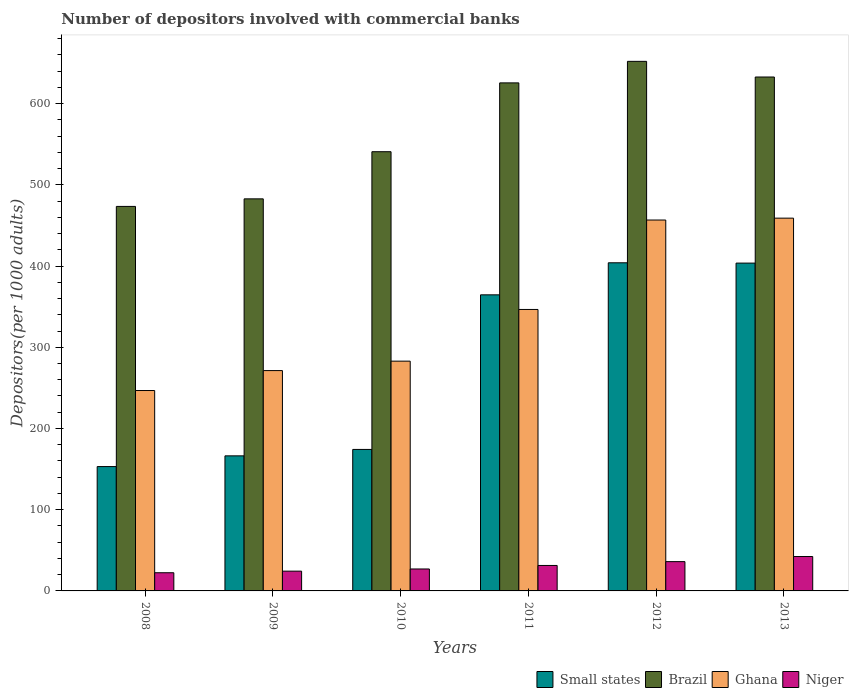How many groups of bars are there?
Offer a terse response. 6. Are the number of bars per tick equal to the number of legend labels?
Offer a terse response. Yes. What is the label of the 3rd group of bars from the left?
Give a very brief answer. 2010. What is the number of depositors involved with commercial banks in Niger in 2010?
Keep it short and to the point. 27.03. Across all years, what is the maximum number of depositors involved with commercial banks in Ghana?
Offer a terse response. 458.97. Across all years, what is the minimum number of depositors involved with commercial banks in Small states?
Offer a terse response. 153.11. In which year was the number of depositors involved with commercial banks in Brazil maximum?
Your response must be concise. 2012. In which year was the number of depositors involved with commercial banks in Brazil minimum?
Your answer should be compact. 2008. What is the total number of depositors involved with commercial banks in Brazil in the graph?
Your response must be concise. 3407.29. What is the difference between the number of depositors involved with commercial banks in Small states in 2012 and that in 2013?
Give a very brief answer. 0.38. What is the difference between the number of depositors involved with commercial banks in Small states in 2008 and the number of depositors involved with commercial banks in Niger in 2012?
Provide a succinct answer. 117.05. What is the average number of depositors involved with commercial banks in Brazil per year?
Your answer should be very brief. 567.88. In the year 2008, what is the difference between the number of depositors involved with commercial banks in Small states and number of depositors involved with commercial banks in Niger?
Provide a succinct answer. 130.72. In how many years, is the number of depositors involved with commercial banks in Ghana greater than 440?
Keep it short and to the point. 2. What is the ratio of the number of depositors involved with commercial banks in Small states in 2009 to that in 2011?
Provide a succinct answer. 0.46. What is the difference between the highest and the second highest number of depositors involved with commercial banks in Small states?
Offer a terse response. 0.38. What is the difference between the highest and the lowest number of depositors involved with commercial banks in Brazil?
Your answer should be very brief. 178.62. Is the sum of the number of depositors involved with commercial banks in Ghana in 2008 and 2011 greater than the maximum number of depositors involved with commercial banks in Niger across all years?
Offer a terse response. Yes. Is it the case that in every year, the sum of the number of depositors involved with commercial banks in Brazil and number of depositors involved with commercial banks in Niger is greater than the sum of number of depositors involved with commercial banks in Ghana and number of depositors involved with commercial banks in Small states?
Give a very brief answer. Yes. What does the 4th bar from the left in 2012 represents?
Provide a short and direct response. Niger. What does the 4th bar from the right in 2009 represents?
Ensure brevity in your answer.  Small states. How many bars are there?
Offer a terse response. 24. Are all the bars in the graph horizontal?
Make the answer very short. No. Does the graph contain any zero values?
Offer a very short reply. No. Where does the legend appear in the graph?
Offer a terse response. Bottom right. How are the legend labels stacked?
Offer a terse response. Horizontal. What is the title of the graph?
Your answer should be very brief. Number of depositors involved with commercial banks. What is the label or title of the X-axis?
Ensure brevity in your answer.  Years. What is the label or title of the Y-axis?
Provide a short and direct response. Depositors(per 1000 adults). What is the Depositors(per 1000 adults) in Small states in 2008?
Provide a succinct answer. 153.11. What is the Depositors(per 1000 adults) in Brazil in 2008?
Give a very brief answer. 473.42. What is the Depositors(per 1000 adults) of Ghana in 2008?
Your answer should be very brief. 246.75. What is the Depositors(per 1000 adults) of Niger in 2008?
Keep it short and to the point. 22.38. What is the Depositors(per 1000 adults) in Small states in 2009?
Provide a succinct answer. 166.31. What is the Depositors(per 1000 adults) in Brazil in 2009?
Offer a very short reply. 482.74. What is the Depositors(per 1000 adults) of Ghana in 2009?
Provide a short and direct response. 271.28. What is the Depositors(per 1000 adults) of Niger in 2009?
Ensure brevity in your answer.  24.34. What is the Depositors(per 1000 adults) of Small states in 2010?
Your answer should be very brief. 174.21. What is the Depositors(per 1000 adults) of Brazil in 2010?
Provide a short and direct response. 540.79. What is the Depositors(per 1000 adults) of Ghana in 2010?
Provide a succinct answer. 282.91. What is the Depositors(per 1000 adults) in Niger in 2010?
Provide a short and direct response. 27.03. What is the Depositors(per 1000 adults) in Small states in 2011?
Provide a short and direct response. 364.57. What is the Depositors(per 1000 adults) of Brazil in 2011?
Make the answer very short. 625.53. What is the Depositors(per 1000 adults) of Ghana in 2011?
Your response must be concise. 346.55. What is the Depositors(per 1000 adults) of Niger in 2011?
Your answer should be compact. 31.35. What is the Depositors(per 1000 adults) of Small states in 2012?
Make the answer very short. 404.02. What is the Depositors(per 1000 adults) in Brazil in 2012?
Your answer should be compact. 652.04. What is the Depositors(per 1000 adults) of Ghana in 2012?
Make the answer very short. 456.67. What is the Depositors(per 1000 adults) in Niger in 2012?
Your answer should be compact. 36.05. What is the Depositors(per 1000 adults) in Small states in 2013?
Provide a short and direct response. 403.64. What is the Depositors(per 1000 adults) of Brazil in 2013?
Provide a succinct answer. 632.77. What is the Depositors(per 1000 adults) of Ghana in 2013?
Offer a very short reply. 458.97. What is the Depositors(per 1000 adults) in Niger in 2013?
Offer a terse response. 42.35. Across all years, what is the maximum Depositors(per 1000 adults) in Small states?
Offer a very short reply. 404.02. Across all years, what is the maximum Depositors(per 1000 adults) in Brazil?
Offer a very short reply. 652.04. Across all years, what is the maximum Depositors(per 1000 adults) in Ghana?
Offer a terse response. 458.97. Across all years, what is the maximum Depositors(per 1000 adults) of Niger?
Your answer should be compact. 42.35. Across all years, what is the minimum Depositors(per 1000 adults) in Small states?
Offer a terse response. 153.11. Across all years, what is the minimum Depositors(per 1000 adults) of Brazil?
Keep it short and to the point. 473.42. Across all years, what is the minimum Depositors(per 1000 adults) of Ghana?
Offer a very short reply. 246.75. Across all years, what is the minimum Depositors(per 1000 adults) of Niger?
Provide a succinct answer. 22.38. What is the total Depositors(per 1000 adults) in Small states in the graph?
Ensure brevity in your answer.  1665.85. What is the total Depositors(per 1000 adults) in Brazil in the graph?
Offer a terse response. 3407.29. What is the total Depositors(per 1000 adults) of Ghana in the graph?
Ensure brevity in your answer.  2063.13. What is the total Depositors(per 1000 adults) of Niger in the graph?
Your answer should be compact. 183.51. What is the difference between the Depositors(per 1000 adults) in Small states in 2008 and that in 2009?
Provide a succinct answer. -13.2. What is the difference between the Depositors(per 1000 adults) of Brazil in 2008 and that in 2009?
Your response must be concise. -9.32. What is the difference between the Depositors(per 1000 adults) of Ghana in 2008 and that in 2009?
Your answer should be very brief. -24.54. What is the difference between the Depositors(per 1000 adults) in Niger in 2008 and that in 2009?
Offer a very short reply. -1.96. What is the difference between the Depositors(per 1000 adults) in Small states in 2008 and that in 2010?
Provide a succinct answer. -21.11. What is the difference between the Depositors(per 1000 adults) of Brazil in 2008 and that in 2010?
Your answer should be compact. -67.37. What is the difference between the Depositors(per 1000 adults) in Ghana in 2008 and that in 2010?
Your answer should be very brief. -36.17. What is the difference between the Depositors(per 1000 adults) of Niger in 2008 and that in 2010?
Your response must be concise. -4.64. What is the difference between the Depositors(per 1000 adults) in Small states in 2008 and that in 2011?
Your response must be concise. -211.46. What is the difference between the Depositors(per 1000 adults) in Brazil in 2008 and that in 2011?
Your response must be concise. -152.11. What is the difference between the Depositors(per 1000 adults) in Ghana in 2008 and that in 2011?
Provide a short and direct response. -99.8. What is the difference between the Depositors(per 1000 adults) of Niger in 2008 and that in 2011?
Ensure brevity in your answer.  -8.96. What is the difference between the Depositors(per 1000 adults) of Small states in 2008 and that in 2012?
Make the answer very short. -250.91. What is the difference between the Depositors(per 1000 adults) of Brazil in 2008 and that in 2012?
Ensure brevity in your answer.  -178.62. What is the difference between the Depositors(per 1000 adults) of Ghana in 2008 and that in 2012?
Offer a terse response. -209.93. What is the difference between the Depositors(per 1000 adults) in Niger in 2008 and that in 2012?
Your answer should be very brief. -13.67. What is the difference between the Depositors(per 1000 adults) of Small states in 2008 and that in 2013?
Your answer should be compact. -250.53. What is the difference between the Depositors(per 1000 adults) of Brazil in 2008 and that in 2013?
Provide a succinct answer. -159.34. What is the difference between the Depositors(per 1000 adults) of Ghana in 2008 and that in 2013?
Your answer should be very brief. -212.23. What is the difference between the Depositors(per 1000 adults) in Niger in 2008 and that in 2013?
Ensure brevity in your answer.  -19.97. What is the difference between the Depositors(per 1000 adults) of Small states in 2009 and that in 2010?
Give a very brief answer. -7.91. What is the difference between the Depositors(per 1000 adults) of Brazil in 2009 and that in 2010?
Provide a succinct answer. -58.05. What is the difference between the Depositors(per 1000 adults) of Ghana in 2009 and that in 2010?
Keep it short and to the point. -11.63. What is the difference between the Depositors(per 1000 adults) in Niger in 2009 and that in 2010?
Provide a short and direct response. -2.68. What is the difference between the Depositors(per 1000 adults) in Small states in 2009 and that in 2011?
Your answer should be very brief. -198.26. What is the difference between the Depositors(per 1000 adults) in Brazil in 2009 and that in 2011?
Keep it short and to the point. -142.79. What is the difference between the Depositors(per 1000 adults) of Ghana in 2009 and that in 2011?
Offer a terse response. -75.26. What is the difference between the Depositors(per 1000 adults) in Niger in 2009 and that in 2011?
Keep it short and to the point. -7. What is the difference between the Depositors(per 1000 adults) of Small states in 2009 and that in 2012?
Your answer should be compact. -237.71. What is the difference between the Depositors(per 1000 adults) in Brazil in 2009 and that in 2012?
Provide a succinct answer. -169.3. What is the difference between the Depositors(per 1000 adults) in Ghana in 2009 and that in 2012?
Offer a terse response. -185.39. What is the difference between the Depositors(per 1000 adults) in Niger in 2009 and that in 2012?
Keep it short and to the point. -11.71. What is the difference between the Depositors(per 1000 adults) of Small states in 2009 and that in 2013?
Provide a succinct answer. -237.33. What is the difference between the Depositors(per 1000 adults) of Brazil in 2009 and that in 2013?
Offer a terse response. -150.03. What is the difference between the Depositors(per 1000 adults) in Ghana in 2009 and that in 2013?
Give a very brief answer. -187.69. What is the difference between the Depositors(per 1000 adults) of Niger in 2009 and that in 2013?
Your response must be concise. -18.01. What is the difference between the Depositors(per 1000 adults) in Small states in 2010 and that in 2011?
Offer a very short reply. -190.35. What is the difference between the Depositors(per 1000 adults) in Brazil in 2010 and that in 2011?
Make the answer very short. -84.74. What is the difference between the Depositors(per 1000 adults) in Ghana in 2010 and that in 2011?
Your response must be concise. -63.63. What is the difference between the Depositors(per 1000 adults) in Niger in 2010 and that in 2011?
Your response must be concise. -4.32. What is the difference between the Depositors(per 1000 adults) of Small states in 2010 and that in 2012?
Keep it short and to the point. -229.8. What is the difference between the Depositors(per 1000 adults) in Brazil in 2010 and that in 2012?
Offer a terse response. -111.25. What is the difference between the Depositors(per 1000 adults) of Ghana in 2010 and that in 2012?
Offer a terse response. -173.76. What is the difference between the Depositors(per 1000 adults) in Niger in 2010 and that in 2012?
Provide a succinct answer. -9.02. What is the difference between the Depositors(per 1000 adults) in Small states in 2010 and that in 2013?
Ensure brevity in your answer.  -229.42. What is the difference between the Depositors(per 1000 adults) in Brazil in 2010 and that in 2013?
Keep it short and to the point. -91.97. What is the difference between the Depositors(per 1000 adults) in Ghana in 2010 and that in 2013?
Provide a succinct answer. -176.06. What is the difference between the Depositors(per 1000 adults) in Niger in 2010 and that in 2013?
Provide a short and direct response. -15.33. What is the difference between the Depositors(per 1000 adults) of Small states in 2011 and that in 2012?
Ensure brevity in your answer.  -39.45. What is the difference between the Depositors(per 1000 adults) in Brazil in 2011 and that in 2012?
Your answer should be compact. -26.51. What is the difference between the Depositors(per 1000 adults) of Ghana in 2011 and that in 2012?
Make the answer very short. -110.13. What is the difference between the Depositors(per 1000 adults) of Niger in 2011 and that in 2012?
Give a very brief answer. -4.71. What is the difference between the Depositors(per 1000 adults) of Small states in 2011 and that in 2013?
Keep it short and to the point. -39.07. What is the difference between the Depositors(per 1000 adults) in Brazil in 2011 and that in 2013?
Offer a terse response. -7.23. What is the difference between the Depositors(per 1000 adults) in Ghana in 2011 and that in 2013?
Your response must be concise. -112.43. What is the difference between the Depositors(per 1000 adults) of Niger in 2011 and that in 2013?
Make the answer very short. -11.01. What is the difference between the Depositors(per 1000 adults) of Small states in 2012 and that in 2013?
Provide a succinct answer. 0.38. What is the difference between the Depositors(per 1000 adults) in Brazil in 2012 and that in 2013?
Offer a terse response. 19.27. What is the difference between the Depositors(per 1000 adults) of Ghana in 2012 and that in 2013?
Your response must be concise. -2.3. What is the difference between the Depositors(per 1000 adults) in Niger in 2012 and that in 2013?
Provide a succinct answer. -6.3. What is the difference between the Depositors(per 1000 adults) in Small states in 2008 and the Depositors(per 1000 adults) in Brazil in 2009?
Make the answer very short. -329.63. What is the difference between the Depositors(per 1000 adults) in Small states in 2008 and the Depositors(per 1000 adults) in Ghana in 2009?
Offer a very short reply. -118.18. What is the difference between the Depositors(per 1000 adults) in Small states in 2008 and the Depositors(per 1000 adults) in Niger in 2009?
Ensure brevity in your answer.  128.76. What is the difference between the Depositors(per 1000 adults) in Brazil in 2008 and the Depositors(per 1000 adults) in Ghana in 2009?
Your response must be concise. 202.14. What is the difference between the Depositors(per 1000 adults) in Brazil in 2008 and the Depositors(per 1000 adults) in Niger in 2009?
Keep it short and to the point. 449.08. What is the difference between the Depositors(per 1000 adults) of Ghana in 2008 and the Depositors(per 1000 adults) of Niger in 2009?
Your answer should be very brief. 222.4. What is the difference between the Depositors(per 1000 adults) in Small states in 2008 and the Depositors(per 1000 adults) in Brazil in 2010?
Keep it short and to the point. -387.69. What is the difference between the Depositors(per 1000 adults) of Small states in 2008 and the Depositors(per 1000 adults) of Ghana in 2010?
Provide a short and direct response. -129.81. What is the difference between the Depositors(per 1000 adults) in Small states in 2008 and the Depositors(per 1000 adults) in Niger in 2010?
Give a very brief answer. 126.08. What is the difference between the Depositors(per 1000 adults) of Brazil in 2008 and the Depositors(per 1000 adults) of Ghana in 2010?
Give a very brief answer. 190.51. What is the difference between the Depositors(per 1000 adults) of Brazil in 2008 and the Depositors(per 1000 adults) of Niger in 2010?
Keep it short and to the point. 446.39. What is the difference between the Depositors(per 1000 adults) of Ghana in 2008 and the Depositors(per 1000 adults) of Niger in 2010?
Ensure brevity in your answer.  219.72. What is the difference between the Depositors(per 1000 adults) of Small states in 2008 and the Depositors(per 1000 adults) of Brazil in 2011?
Give a very brief answer. -472.42. What is the difference between the Depositors(per 1000 adults) of Small states in 2008 and the Depositors(per 1000 adults) of Ghana in 2011?
Offer a terse response. -193.44. What is the difference between the Depositors(per 1000 adults) in Small states in 2008 and the Depositors(per 1000 adults) in Niger in 2011?
Your answer should be very brief. 121.76. What is the difference between the Depositors(per 1000 adults) in Brazil in 2008 and the Depositors(per 1000 adults) in Ghana in 2011?
Provide a short and direct response. 126.88. What is the difference between the Depositors(per 1000 adults) in Brazil in 2008 and the Depositors(per 1000 adults) in Niger in 2011?
Keep it short and to the point. 442.08. What is the difference between the Depositors(per 1000 adults) in Ghana in 2008 and the Depositors(per 1000 adults) in Niger in 2011?
Make the answer very short. 215.4. What is the difference between the Depositors(per 1000 adults) in Small states in 2008 and the Depositors(per 1000 adults) in Brazil in 2012?
Provide a short and direct response. -498.93. What is the difference between the Depositors(per 1000 adults) of Small states in 2008 and the Depositors(per 1000 adults) of Ghana in 2012?
Provide a succinct answer. -303.57. What is the difference between the Depositors(per 1000 adults) in Small states in 2008 and the Depositors(per 1000 adults) in Niger in 2012?
Offer a terse response. 117.05. What is the difference between the Depositors(per 1000 adults) in Brazil in 2008 and the Depositors(per 1000 adults) in Ghana in 2012?
Offer a terse response. 16.75. What is the difference between the Depositors(per 1000 adults) in Brazil in 2008 and the Depositors(per 1000 adults) in Niger in 2012?
Offer a very short reply. 437.37. What is the difference between the Depositors(per 1000 adults) of Ghana in 2008 and the Depositors(per 1000 adults) of Niger in 2012?
Give a very brief answer. 210.69. What is the difference between the Depositors(per 1000 adults) of Small states in 2008 and the Depositors(per 1000 adults) of Brazil in 2013?
Make the answer very short. -479.66. What is the difference between the Depositors(per 1000 adults) in Small states in 2008 and the Depositors(per 1000 adults) in Ghana in 2013?
Offer a very short reply. -305.87. What is the difference between the Depositors(per 1000 adults) of Small states in 2008 and the Depositors(per 1000 adults) of Niger in 2013?
Provide a succinct answer. 110.75. What is the difference between the Depositors(per 1000 adults) in Brazil in 2008 and the Depositors(per 1000 adults) in Ghana in 2013?
Your answer should be very brief. 14.45. What is the difference between the Depositors(per 1000 adults) in Brazil in 2008 and the Depositors(per 1000 adults) in Niger in 2013?
Your answer should be compact. 431.07. What is the difference between the Depositors(per 1000 adults) of Ghana in 2008 and the Depositors(per 1000 adults) of Niger in 2013?
Your answer should be very brief. 204.39. What is the difference between the Depositors(per 1000 adults) in Small states in 2009 and the Depositors(per 1000 adults) in Brazil in 2010?
Give a very brief answer. -374.49. What is the difference between the Depositors(per 1000 adults) in Small states in 2009 and the Depositors(per 1000 adults) in Ghana in 2010?
Provide a succinct answer. -116.61. What is the difference between the Depositors(per 1000 adults) in Small states in 2009 and the Depositors(per 1000 adults) in Niger in 2010?
Your response must be concise. 139.28. What is the difference between the Depositors(per 1000 adults) in Brazil in 2009 and the Depositors(per 1000 adults) in Ghana in 2010?
Provide a succinct answer. 199.83. What is the difference between the Depositors(per 1000 adults) in Brazil in 2009 and the Depositors(per 1000 adults) in Niger in 2010?
Provide a succinct answer. 455.71. What is the difference between the Depositors(per 1000 adults) in Ghana in 2009 and the Depositors(per 1000 adults) in Niger in 2010?
Offer a very short reply. 244.25. What is the difference between the Depositors(per 1000 adults) in Small states in 2009 and the Depositors(per 1000 adults) in Brazil in 2011?
Ensure brevity in your answer.  -459.22. What is the difference between the Depositors(per 1000 adults) in Small states in 2009 and the Depositors(per 1000 adults) in Ghana in 2011?
Your answer should be very brief. -180.24. What is the difference between the Depositors(per 1000 adults) in Small states in 2009 and the Depositors(per 1000 adults) in Niger in 2011?
Your response must be concise. 134.96. What is the difference between the Depositors(per 1000 adults) in Brazil in 2009 and the Depositors(per 1000 adults) in Ghana in 2011?
Provide a short and direct response. 136.19. What is the difference between the Depositors(per 1000 adults) in Brazil in 2009 and the Depositors(per 1000 adults) in Niger in 2011?
Keep it short and to the point. 451.39. What is the difference between the Depositors(per 1000 adults) of Ghana in 2009 and the Depositors(per 1000 adults) of Niger in 2011?
Your answer should be very brief. 239.94. What is the difference between the Depositors(per 1000 adults) in Small states in 2009 and the Depositors(per 1000 adults) in Brazil in 2012?
Your response must be concise. -485.73. What is the difference between the Depositors(per 1000 adults) of Small states in 2009 and the Depositors(per 1000 adults) of Ghana in 2012?
Offer a terse response. -290.37. What is the difference between the Depositors(per 1000 adults) in Small states in 2009 and the Depositors(per 1000 adults) in Niger in 2012?
Offer a terse response. 130.25. What is the difference between the Depositors(per 1000 adults) of Brazil in 2009 and the Depositors(per 1000 adults) of Ghana in 2012?
Offer a terse response. 26.07. What is the difference between the Depositors(per 1000 adults) of Brazil in 2009 and the Depositors(per 1000 adults) of Niger in 2012?
Offer a terse response. 446.69. What is the difference between the Depositors(per 1000 adults) in Ghana in 2009 and the Depositors(per 1000 adults) in Niger in 2012?
Provide a succinct answer. 235.23. What is the difference between the Depositors(per 1000 adults) of Small states in 2009 and the Depositors(per 1000 adults) of Brazil in 2013?
Offer a terse response. -466.46. What is the difference between the Depositors(per 1000 adults) of Small states in 2009 and the Depositors(per 1000 adults) of Ghana in 2013?
Give a very brief answer. -292.67. What is the difference between the Depositors(per 1000 adults) of Small states in 2009 and the Depositors(per 1000 adults) of Niger in 2013?
Give a very brief answer. 123.95. What is the difference between the Depositors(per 1000 adults) of Brazil in 2009 and the Depositors(per 1000 adults) of Ghana in 2013?
Keep it short and to the point. 23.77. What is the difference between the Depositors(per 1000 adults) of Brazil in 2009 and the Depositors(per 1000 adults) of Niger in 2013?
Provide a succinct answer. 440.39. What is the difference between the Depositors(per 1000 adults) in Ghana in 2009 and the Depositors(per 1000 adults) in Niger in 2013?
Your response must be concise. 228.93. What is the difference between the Depositors(per 1000 adults) of Small states in 2010 and the Depositors(per 1000 adults) of Brazil in 2011?
Offer a terse response. -451.32. What is the difference between the Depositors(per 1000 adults) of Small states in 2010 and the Depositors(per 1000 adults) of Ghana in 2011?
Keep it short and to the point. -172.33. What is the difference between the Depositors(per 1000 adults) of Small states in 2010 and the Depositors(per 1000 adults) of Niger in 2011?
Offer a very short reply. 142.87. What is the difference between the Depositors(per 1000 adults) in Brazil in 2010 and the Depositors(per 1000 adults) in Ghana in 2011?
Offer a terse response. 194.25. What is the difference between the Depositors(per 1000 adults) in Brazil in 2010 and the Depositors(per 1000 adults) in Niger in 2011?
Your answer should be very brief. 509.45. What is the difference between the Depositors(per 1000 adults) of Ghana in 2010 and the Depositors(per 1000 adults) of Niger in 2011?
Keep it short and to the point. 251.57. What is the difference between the Depositors(per 1000 adults) in Small states in 2010 and the Depositors(per 1000 adults) in Brazil in 2012?
Keep it short and to the point. -477.82. What is the difference between the Depositors(per 1000 adults) of Small states in 2010 and the Depositors(per 1000 adults) of Ghana in 2012?
Your answer should be very brief. -282.46. What is the difference between the Depositors(per 1000 adults) in Small states in 2010 and the Depositors(per 1000 adults) in Niger in 2012?
Make the answer very short. 138.16. What is the difference between the Depositors(per 1000 adults) in Brazil in 2010 and the Depositors(per 1000 adults) in Ghana in 2012?
Offer a terse response. 84.12. What is the difference between the Depositors(per 1000 adults) in Brazil in 2010 and the Depositors(per 1000 adults) in Niger in 2012?
Give a very brief answer. 504.74. What is the difference between the Depositors(per 1000 adults) of Ghana in 2010 and the Depositors(per 1000 adults) of Niger in 2012?
Provide a succinct answer. 246.86. What is the difference between the Depositors(per 1000 adults) of Small states in 2010 and the Depositors(per 1000 adults) of Brazil in 2013?
Keep it short and to the point. -458.55. What is the difference between the Depositors(per 1000 adults) of Small states in 2010 and the Depositors(per 1000 adults) of Ghana in 2013?
Ensure brevity in your answer.  -284.76. What is the difference between the Depositors(per 1000 adults) in Small states in 2010 and the Depositors(per 1000 adults) in Niger in 2013?
Ensure brevity in your answer.  131.86. What is the difference between the Depositors(per 1000 adults) of Brazil in 2010 and the Depositors(per 1000 adults) of Ghana in 2013?
Keep it short and to the point. 81.82. What is the difference between the Depositors(per 1000 adults) of Brazil in 2010 and the Depositors(per 1000 adults) of Niger in 2013?
Your answer should be very brief. 498.44. What is the difference between the Depositors(per 1000 adults) in Ghana in 2010 and the Depositors(per 1000 adults) in Niger in 2013?
Provide a succinct answer. 240.56. What is the difference between the Depositors(per 1000 adults) in Small states in 2011 and the Depositors(per 1000 adults) in Brazil in 2012?
Give a very brief answer. -287.47. What is the difference between the Depositors(per 1000 adults) in Small states in 2011 and the Depositors(per 1000 adults) in Ghana in 2012?
Provide a succinct answer. -92.11. What is the difference between the Depositors(per 1000 adults) of Small states in 2011 and the Depositors(per 1000 adults) of Niger in 2012?
Provide a succinct answer. 328.51. What is the difference between the Depositors(per 1000 adults) in Brazil in 2011 and the Depositors(per 1000 adults) in Ghana in 2012?
Your response must be concise. 168.86. What is the difference between the Depositors(per 1000 adults) of Brazil in 2011 and the Depositors(per 1000 adults) of Niger in 2012?
Your answer should be compact. 589.48. What is the difference between the Depositors(per 1000 adults) of Ghana in 2011 and the Depositors(per 1000 adults) of Niger in 2012?
Your answer should be very brief. 310.49. What is the difference between the Depositors(per 1000 adults) of Small states in 2011 and the Depositors(per 1000 adults) of Brazil in 2013?
Your answer should be very brief. -268.2. What is the difference between the Depositors(per 1000 adults) of Small states in 2011 and the Depositors(per 1000 adults) of Ghana in 2013?
Provide a succinct answer. -94.41. What is the difference between the Depositors(per 1000 adults) of Small states in 2011 and the Depositors(per 1000 adults) of Niger in 2013?
Offer a very short reply. 322.21. What is the difference between the Depositors(per 1000 adults) in Brazil in 2011 and the Depositors(per 1000 adults) in Ghana in 2013?
Provide a succinct answer. 166.56. What is the difference between the Depositors(per 1000 adults) in Brazil in 2011 and the Depositors(per 1000 adults) in Niger in 2013?
Provide a short and direct response. 583.18. What is the difference between the Depositors(per 1000 adults) of Ghana in 2011 and the Depositors(per 1000 adults) of Niger in 2013?
Provide a short and direct response. 304.19. What is the difference between the Depositors(per 1000 adults) of Small states in 2012 and the Depositors(per 1000 adults) of Brazil in 2013?
Make the answer very short. -228.75. What is the difference between the Depositors(per 1000 adults) in Small states in 2012 and the Depositors(per 1000 adults) in Ghana in 2013?
Your response must be concise. -54.96. What is the difference between the Depositors(per 1000 adults) of Small states in 2012 and the Depositors(per 1000 adults) of Niger in 2013?
Provide a succinct answer. 361.66. What is the difference between the Depositors(per 1000 adults) of Brazil in 2012 and the Depositors(per 1000 adults) of Ghana in 2013?
Your response must be concise. 193.06. What is the difference between the Depositors(per 1000 adults) in Brazil in 2012 and the Depositors(per 1000 adults) in Niger in 2013?
Provide a succinct answer. 609.68. What is the difference between the Depositors(per 1000 adults) in Ghana in 2012 and the Depositors(per 1000 adults) in Niger in 2013?
Offer a very short reply. 414.32. What is the average Depositors(per 1000 adults) in Small states per year?
Provide a succinct answer. 277.64. What is the average Depositors(per 1000 adults) in Brazil per year?
Provide a succinct answer. 567.88. What is the average Depositors(per 1000 adults) in Ghana per year?
Keep it short and to the point. 343.86. What is the average Depositors(per 1000 adults) in Niger per year?
Your answer should be compact. 30.58. In the year 2008, what is the difference between the Depositors(per 1000 adults) of Small states and Depositors(per 1000 adults) of Brazil?
Your response must be concise. -320.32. In the year 2008, what is the difference between the Depositors(per 1000 adults) of Small states and Depositors(per 1000 adults) of Ghana?
Your response must be concise. -93.64. In the year 2008, what is the difference between the Depositors(per 1000 adults) in Small states and Depositors(per 1000 adults) in Niger?
Provide a short and direct response. 130.72. In the year 2008, what is the difference between the Depositors(per 1000 adults) of Brazil and Depositors(per 1000 adults) of Ghana?
Give a very brief answer. 226.68. In the year 2008, what is the difference between the Depositors(per 1000 adults) of Brazil and Depositors(per 1000 adults) of Niger?
Provide a succinct answer. 451.04. In the year 2008, what is the difference between the Depositors(per 1000 adults) of Ghana and Depositors(per 1000 adults) of Niger?
Your answer should be compact. 224.36. In the year 2009, what is the difference between the Depositors(per 1000 adults) in Small states and Depositors(per 1000 adults) in Brazil?
Offer a terse response. -316.43. In the year 2009, what is the difference between the Depositors(per 1000 adults) of Small states and Depositors(per 1000 adults) of Ghana?
Make the answer very short. -104.98. In the year 2009, what is the difference between the Depositors(per 1000 adults) of Small states and Depositors(per 1000 adults) of Niger?
Your response must be concise. 141.96. In the year 2009, what is the difference between the Depositors(per 1000 adults) in Brazil and Depositors(per 1000 adults) in Ghana?
Ensure brevity in your answer.  211.46. In the year 2009, what is the difference between the Depositors(per 1000 adults) in Brazil and Depositors(per 1000 adults) in Niger?
Provide a succinct answer. 458.39. In the year 2009, what is the difference between the Depositors(per 1000 adults) of Ghana and Depositors(per 1000 adults) of Niger?
Your answer should be very brief. 246.94. In the year 2010, what is the difference between the Depositors(per 1000 adults) of Small states and Depositors(per 1000 adults) of Brazil?
Your response must be concise. -366.58. In the year 2010, what is the difference between the Depositors(per 1000 adults) in Small states and Depositors(per 1000 adults) in Ghana?
Offer a very short reply. -108.7. In the year 2010, what is the difference between the Depositors(per 1000 adults) in Small states and Depositors(per 1000 adults) in Niger?
Offer a very short reply. 147.19. In the year 2010, what is the difference between the Depositors(per 1000 adults) in Brazil and Depositors(per 1000 adults) in Ghana?
Offer a very short reply. 257.88. In the year 2010, what is the difference between the Depositors(per 1000 adults) in Brazil and Depositors(per 1000 adults) in Niger?
Make the answer very short. 513.76. In the year 2010, what is the difference between the Depositors(per 1000 adults) of Ghana and Depositors(per 1000 adults) of Niger?
Give a very brief answer. 255.88. In the year 2011, what is the difference between the Depositors(per 1000 adults) of Small states and Depositors(per 1000 adults) of Brazil?
Your answer should be compact. -260.96. In the year 2011, what is the difference between the Depositors(per 1000 adults) of Small states and Depositors(per 1000 adults) of Ghana?
Your response must be concise. 18.02. In the year 2011, what is the difference between the Depositors(per 1000 adults) in Small states and Depositors(per 1000 adults) in Niger?
Offer a very short reply. 333.22. In the year 2011, what is the difference between the Depositors(per 1000 adults) of Brazil and Depositors(per 1000 adults) of Ghana?
Make the answer very short. 278.99. In the year 2011, what is the difference between the Depositors(per 1000 adults) in Brazil and Depositors(per 1000 adults) in Niger?
Your answer should be compact. 594.19. In the year 2011, what is the difference between the Depositors(per 1000 adults) of Ghana and Depositors(per 1000 adults) of Niger?
Offer a very short reply. 315.2. In the year 2012, what is the difference between the Depositors(per 1000 adults) of Small states and Depositors(per 1000 adults) of Brazil?
Offer a terse response. -248.02. In the year 2012, what is the difference between the Depositors(per 1000 adults) of Small states and Depositors(per 1000 adults) of Ghana?
Provide a short and direct response. -52.66. In the year 2012, what is the difference between the Depositors(per 1000 adults) in Small states and Depositors(per 1000 adults) in Niger?
Provide a short and direct response. 367.96. In the year 2012, what is the difference between the Depositors(per 1000 adults) in Brazil and Depositors(per 1000 adults) in Ghana?
Offer a terse response. 195.37. In the year 2012, what is the difference between the Depositors(per 1000 adults) of Brazil and Depositors(per 1000 adults) of Niger?
Your response must be concise. 615.99. In the year 2012, what is the difference between the Depositors(per 1000 adults) of Ghana and Depositors(per 1000 adults) of Niger?
Your response must be concise. 420.62. In the year 2013, what is the difference between the Depositors(per 1000 adults) in Small states and Depositors(per 1000 adults) in Brazil?
Provide a succinct answer. -229.13. In the year 2013, what is the difference between the Depositors(per 1000 adults) in Small states and Depositors(per 1000 adults) in Ghana?
Your response must be concise. -55.34. In the year 2013, what is the difference between the Depositors(per 1000 adults) in Small states and Depositors(per 1000 adults) in Niger?
Provide a succinct answer. 361.28. In the year 2013, what is the difference between the Depositors(per 1000 adults) in Brazil and Depositors(per 1000 adults) in Ghana?
Ensure brevity in your answer.  173.79. In the year 2013, what is the difference between the Depositors(per 1000 adults) in Brazil and Depositors(per 1000 adults) in Niger?
Your answer should be very brief. 590.41. In the year 2013, what is the difference between the Depositors(per 1000 adults) of Ghana and Depositors(per 1000 adults) of Niger?
Your answer should be very brief. 416.62. What is the ratio of the Depositors(per 1000 adults) of Small states in 2008 to that in 2009?
Provide a succinct answer. 0.92. What is the ratio of the Depositors(per 1000 adults) in Brazil in 2008 to that in 2009?
Make the answer very short. 0.98. What is the ratio of the Depositors(per 1000 adults) in Ghana in 2008 to that in 2009?
Ensure brevity in your answer.  0.91. What is the ratio of the Depositors(per 1000 adults) in Niger in 2008 to that in 2009?
Your answer should be compact. 0.92. What is the ratio of the Depositors(per 1000 adults) of Small states in 2008 to that in 2010?
Your answer should be very brief. 0.88. What is the ratio of the Depositors(per 1000 adults) of Brazil in 2008 to that in 2010?
Your answer should be compact. 0.88. What is the ratio of the Depositors(per 1000 adults) of Ghana in 2008 to that in 2010?
Ensure brevity in your answer.  0.87. What is the ratio of the Depositors(per 1000 adults) in Niger in 2008 to that in 2010?
Offer a terse response. 0.83. What is the ratio of the Depositors(per 1000 adults) in Small states in 2008 to that in 2011?
Keep it short and to the point. 0.42. What is the ratio of the Depositors(per 1000 adults) of Brazil in 2008 to that in 2011?
Your answer should be very brief. 0.76. What is the ratio of the Depositors(per 1000 adults) of Ghana in 2008 to that in 2011?
Keep it short and to the point. 0.71. What is the ratio of the Depositors(per 1000 adults) in Niger in 2008 to that in 2011?
Offer a very short reply. 0.71. What is the ratio of the Depositors(per 1000 adults) of Small states in 2008 to that in 2012?
Give a very brief answer. 0.38. What is the ratio of the Depositors(per 1000 adults) of Brazil in 2008 to that in 2012?
Your response must be concise. 0.73. What is the ratio of the Depositors(per 1000 adults) in Ghana in 2008 to that in 2012?
Your answer should be compact. 0.54. What is the ratio of the Depositors(per 1000 adults) in Niger in 2008 to that in 2012?
Make the answer very short. 0.62. What is the ratio of the Depositors(per 1000 adults) of Small states in 2008 to that in 2013?
Make the answer very short. 0.38. What is the ratio of the Depositors(per 1000 adults) of Brazil in 2008 to that in 2013?
Make the answer very short. 0.75. What is the ratio of the Depositors(per 1000 adults) of Ghana in 2008 to that in 2013?
Offer a terse response. 0.54. What is the ratio of the Depositors(per 1000 adults) in Niger in 2008 to that in 2013?
Your response must be concise. 0.53. What is the ratio of the Depositors(per 1000 adults) in Small states in 2009 to that in 2010?
Keep it short and to the point. 0.95. What is the ratio of the Depositors(per 1000 adults) of Brazil in 2009 to that in 2010?
Your answer should be very brief. 0.89. What is the ratio of the Depositors(per 1000 adults) of Ghana in 2009 to that in 2010?
Provide a short and direct response. 0.96. What is the ratio of the Depositors(per 1000 adults) in Niger in 2009 to that in 2010?
Offer a very short reply. 0.9. What is the ratio of the Depositors(per 1000 adults) of Small states in 2009 to that in 2011?
Your answer should be compact. 0.46. What is the ratio of the Depositors(per 1000 adults) of Brazil in 2009 to that in 2011?
Ensure brevity in your answer.  0.77. What is the ratio of the Depositors(per 1000 adults) in Ghana in 2009 to that in 2011?
Offer a very short reply. 0.78. What is the ratio of the Depositors(per 1000 adults) of Niger in 2009 to that in 2011?
Provide a short and direct response. 0.78. What is the ratio of the Depositors(per 1000 adults) in Small states in 2009 to that in 2012?
Keep it short and to the point. 0.41. What is the ratio of the Depositors(per 1000 adults) of Brazil in 2009 to that in 2012?
Your answer should be compact. 0.74. What is the ratio of the Depositors(per 1000 adults) of Ghana in 2009 to that in 2012?
Offer a terse response. 0.59. What is the ratio of the Depositors(per 1000 adults) of Niger in 2009 to that in 2012?
Your answer should be very brief. 0.68. What is the ratio of the Depositors(per 1000 adults) of Small states in 2009 to that in 2013?
Your response must be concise. 0.41. What is the ratio of the Depositors(per 1000 adults) of Brazil in 2009 to that in 2013?
Your answer should be very brief. 0.76. What is the ratio of the Depositors(per 1000 adults) of Ghana in 2009 to that in 2013?
Give a very brief answer. 0.59. What is the ratio of the Depositors(per 1000 adults) of Niger in 2009 to that in 2013?
Keep it short and to the point. 0.57. What is the ratio of the Depositors(per 1000 adults) in Small states in 2010 to that in 2011?
Keep it short and to the point. 0.48. What is the ratio of the Depositors(per 1000 adults) in Brazil in 2010 to that in 2011?
Your answer should be very brief. 0.86. What is the ratio of the Depositors(per 1000 adults) of Ghana in 2010 to that in 2011?
Offer a terse response. 0.82. What is the ratio of the Depositors(per 1000 adults) in Niger in 2010 to that in 2011?
Make the answer very short. 0.86. What is the ratio of the Depositors(per 1000 adults) in Small states in 2010 to that in 2012?
Offer a terse response. 0.43. What is the ratio of the Depositors(per 1000 adults) of Brazil in 2010 to that in 2012?
Keep it short and to the point. 0.83. What is the ratio of the Depositors(per 1000 adults) of Ghana in 2010 to that in 2012?
Offer a very short reply. 0.62. What is the ratio of the Depositors(per 1000 adults) in Niger in 2010 to that in 2012?
Make the answer very short. 0.75. What is the ratio of the Depositors(per 1000 adults) in Small states in 2010 to that in 2013?
Your answer should be compact. 0.43. What is the ratio of the Depositors(per 1000 adults) of Brazil in 2010 to that in 2013?
Provide a short and direct response. 0.85. What is the ratio of the Depositors(per 1000 adults) in Ghana in 2010 to that in 2013?
Give a very brief answer. 0.62. What is the ratio of the Depositors(per 1000 adults) in Niger in 2010 to that in 2013?
Your answer should be compact. 0.64. What is the ratio of the Depositors(per 1000 adults) of Small states in 2011 to that in 2012?
Your answer should be very brief. 0.9. What is the ratio of the Depositors(per 1000 adults) of Brazil in 2011 to that in 2012?
Provide a succinct answer. 0.96. What is the ratio of the Depositors(per 1000 adults) in Ghana in 2011 to that in 2012?
Provide a short and direct response. 0.76. What is the ratio of the Depositors(per 1000 adults) in Niger in 2011 to that in 2012?
Offer a terse response. 0.87. What is the ratio of the Depositors(per 1000 adults) in Small states in 2011 to that in 2013?
Provide a short and direct response. 0.9. What is the ratio of the Depositors(per 1000 adults) in Ghana in 2011 to that in 2013?
Provide a short and direct response. 0.76. What is the ratio of the Depositors(per 1000 adults) of Niger in 2011 to that in 2013?
Provide a short and direct response. 0.74. What is the ratio of the Depositors(per 1000 adults) of Small states in 2012 to that in 2013?
Provide a succinct answer. 1. What is the ratio of the Depositors(per 1000 adults) of Brazil in 2012 to that in 2013?
Ensure brevity in your answer.  1.03. What is the ratio of the Depositors(per 1000 adults) of Ghana in 2012 to that in 2013?
Your answer should be compact. 0.99. What is the ratio of the Depositors(per 1000 adults) of Niger in 2012 to that in 2013?
Make the answer very short. 0.85. What is the difference between the highest and the second highest Depositors(per 1000 adults) in Small states?
Your answer should be very brief. 0.38. What is the difference between the highest and the second highest Depositors(per 1000 adults) in Brazil?
Offer a terse response. 19.27. What is the difference between the highest and the second highest Depositors(per 1000 adults) of Ghana?
Keep it short and to the point. 2.3. What is the difference between the highest and the second highest Depositors(per 1000 adults) in Niger?
Your response must be concise. 6.3. What is the difference between the highest and the lowest Depositors(per 1000 adults) of Small states?
Give a very brief answer. 250.91. What is the difference between the highest and the lowest Depositors(per 1000 adults) in Brazil?
Keep it short and to the point. 178.62. What is the difference between the highest and the lowest Depositors(per 1000 adults) of Ghana?
Ensure brevity in your answer.  212.23. What is the difference between the highest and the lowest Depositors(per 1000 adults) in Niger?
Ensure brevity in your answer.  19.97. 